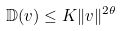Convert formula to latex. <formula><loc_0><loc_0><loc_500><loc_500>\mathbb { D } ( v ) \leq K \| v \| ^ { 2 \theta }</formula> 